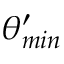<formula> <loc_0><loc_0><loc_500><loc_500>\theta _ { \min } ^ { \prime }</formula> 